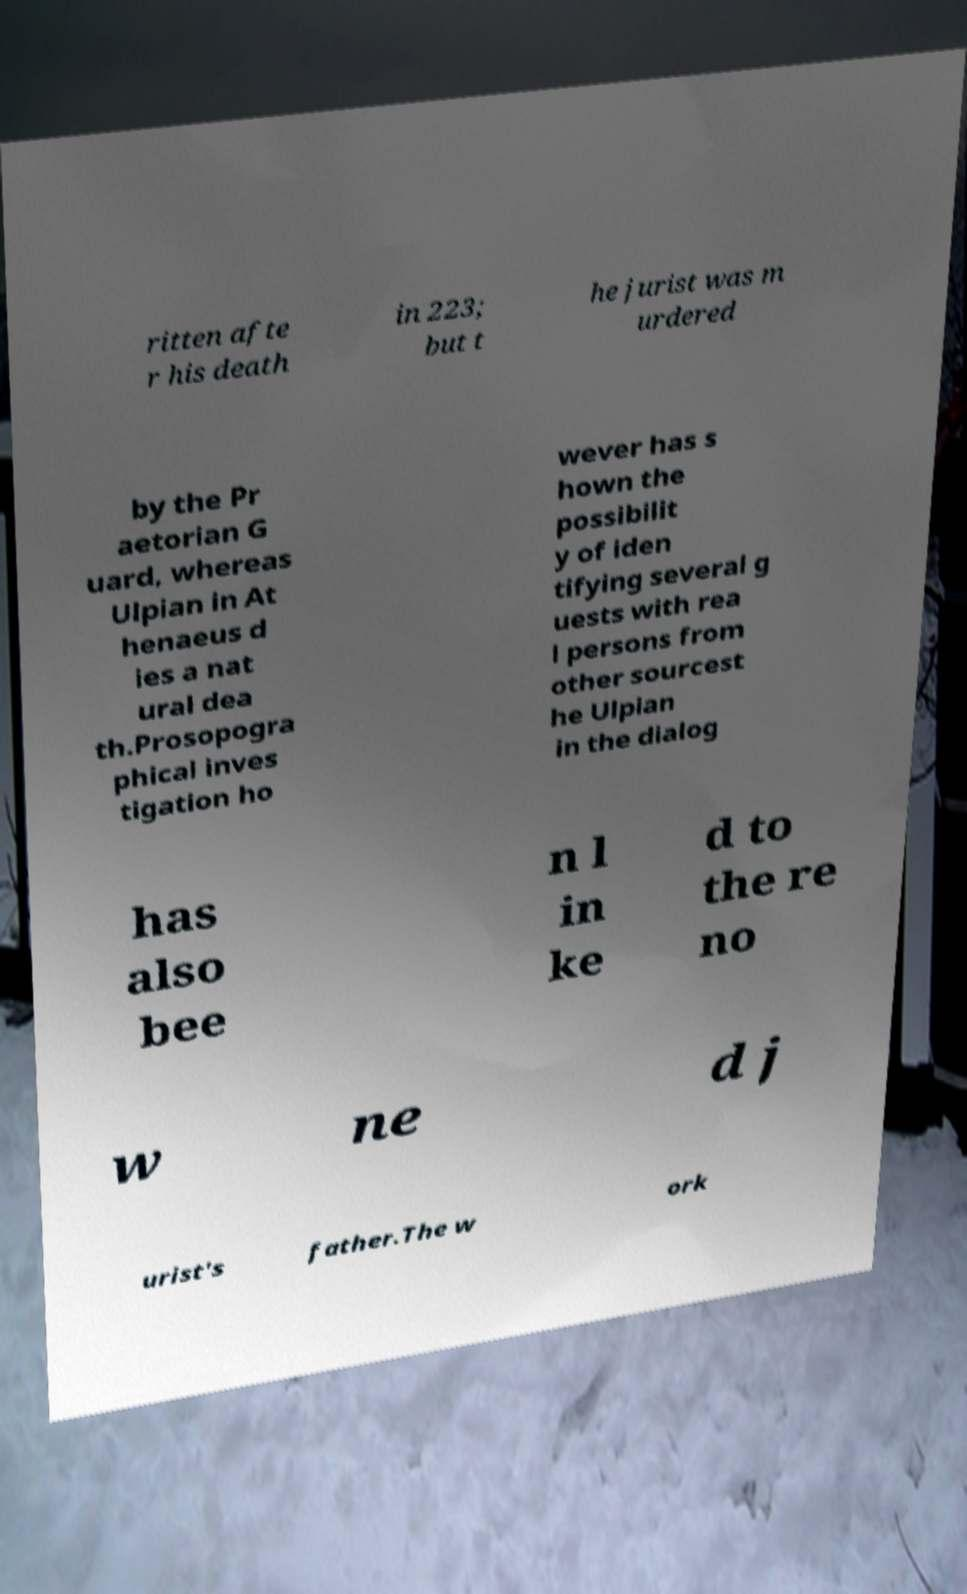Could you assist in decoding the text presented in this image and type it out clearly? ritten afte r his death in 223; but t he jurist was m urdered by the Pr aetorian G uard, whereas Ulpian in At henaeus d ies a nat ural dea th.Prosopogra phical inves tigation ho wever has s hown the possibilit y of iden tifying several g uests with rea l persons from other sourcest he Ulpian in the dialog has also bee n l in ke d to the re no w ne d j urist's father.The w ork 